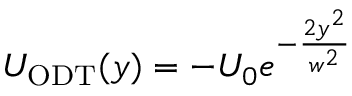Convert formula to latex. <formula><loc_0><loc_0><loc_500><loc_500>U _ { O D T } ( y ) = - U _ { 0 } e ^ { - \frac { 2 y ^ { 2 } } { w ^ { 2 } } }</formula> 